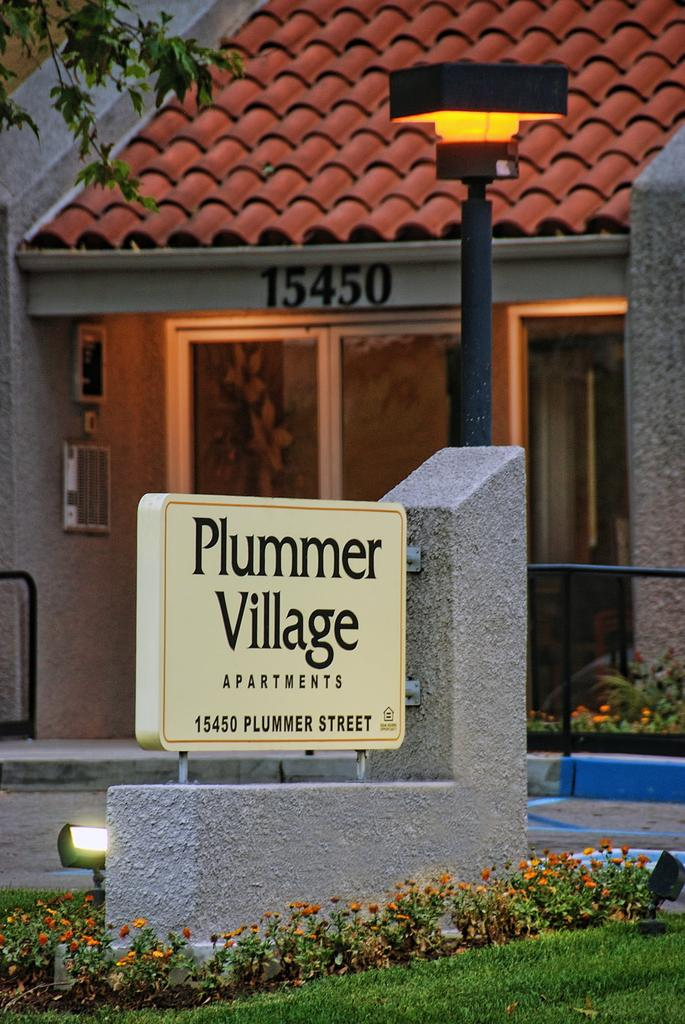What is the main object in the image? There is a sign board in the image. What is located beside the sign board? There are plants beside the sign board. What type of flora can be seen in the image? There are flowers in the image. What type of illumination is present in the image? There are lights in the image. What structure can be seen in the image? There is a pole in the image. What can be seen in the background of the image? There is a house and a tree in the background of the image. What causes the sign board to feel regret in the image? There is no indication of regret in the image, as it is an inanimate object. What mark can be seen on the throat of the person in the image? There is no person present in the image, so it is not possible to observe any marks on a throat. 